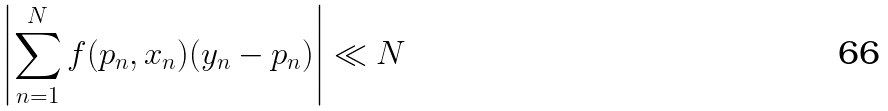Convert formula to latex. <formula><loc_0><loc_0><loc_500><loc_500>\left | \sum _ { n = 1 } ^ { N } f ( p _ { n } , x _ { n } ) ( y _ { n } - p _ { n } ) \right | \ll N</formula> 